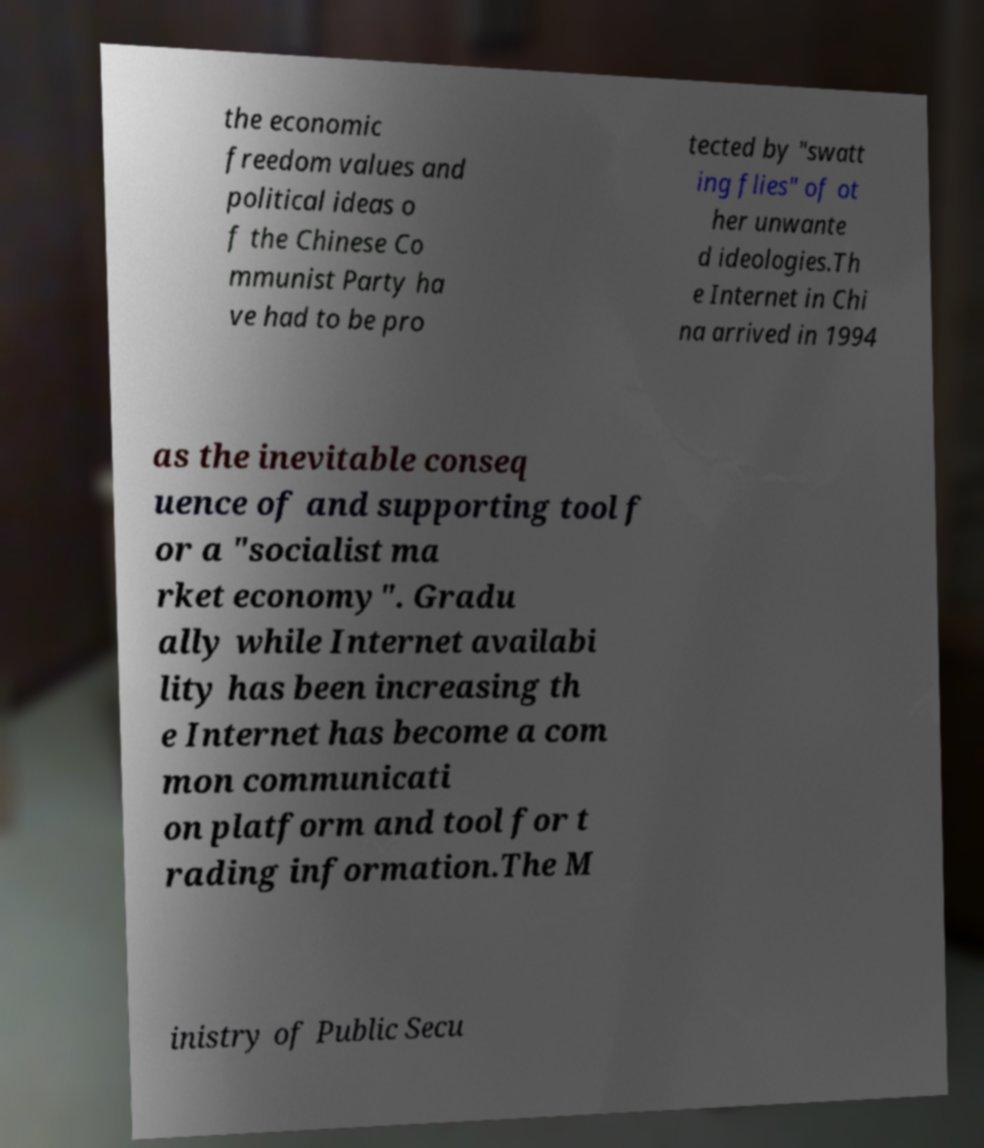Could you assist in decoding the text presented in this image and type it out clearly? the economic freedom values and political ideas o f the Chinese Co mmunist Party ha ve had to be pro tected by "swatt ing flies" of ot her unwante d ideologies.Th e Internet in Chi na arrived in 1994 as the inevitable conseq uence of and supporting tool f or a "socialist ma rket economy". Gradu ally while Internet availabi lity has been increasing th e Internet has become a com mon communicati on platform and tool for t rading information.The M inistry of Public Secu 